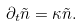Convert formula to latex. <formula><loc_0><loc_0><loc_500><loc_500>\partial _ { t } \tilde { n } = \kappa \tilde { n } .</formula> 